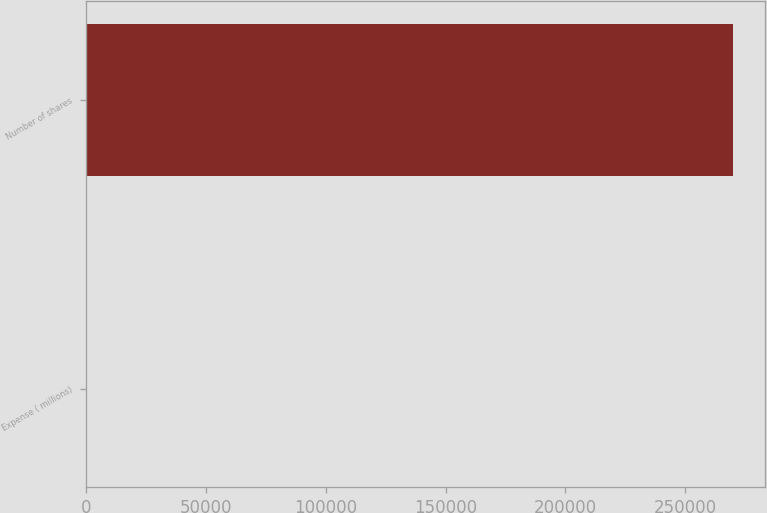Convert chart. <chart><loc_0><loc_0><loc_500><loc_500><bar_chart><fcel>Expense ( millions)<fcel>Number of shares<nl><fcel>10.7<fcel>269896<nl></chart> 